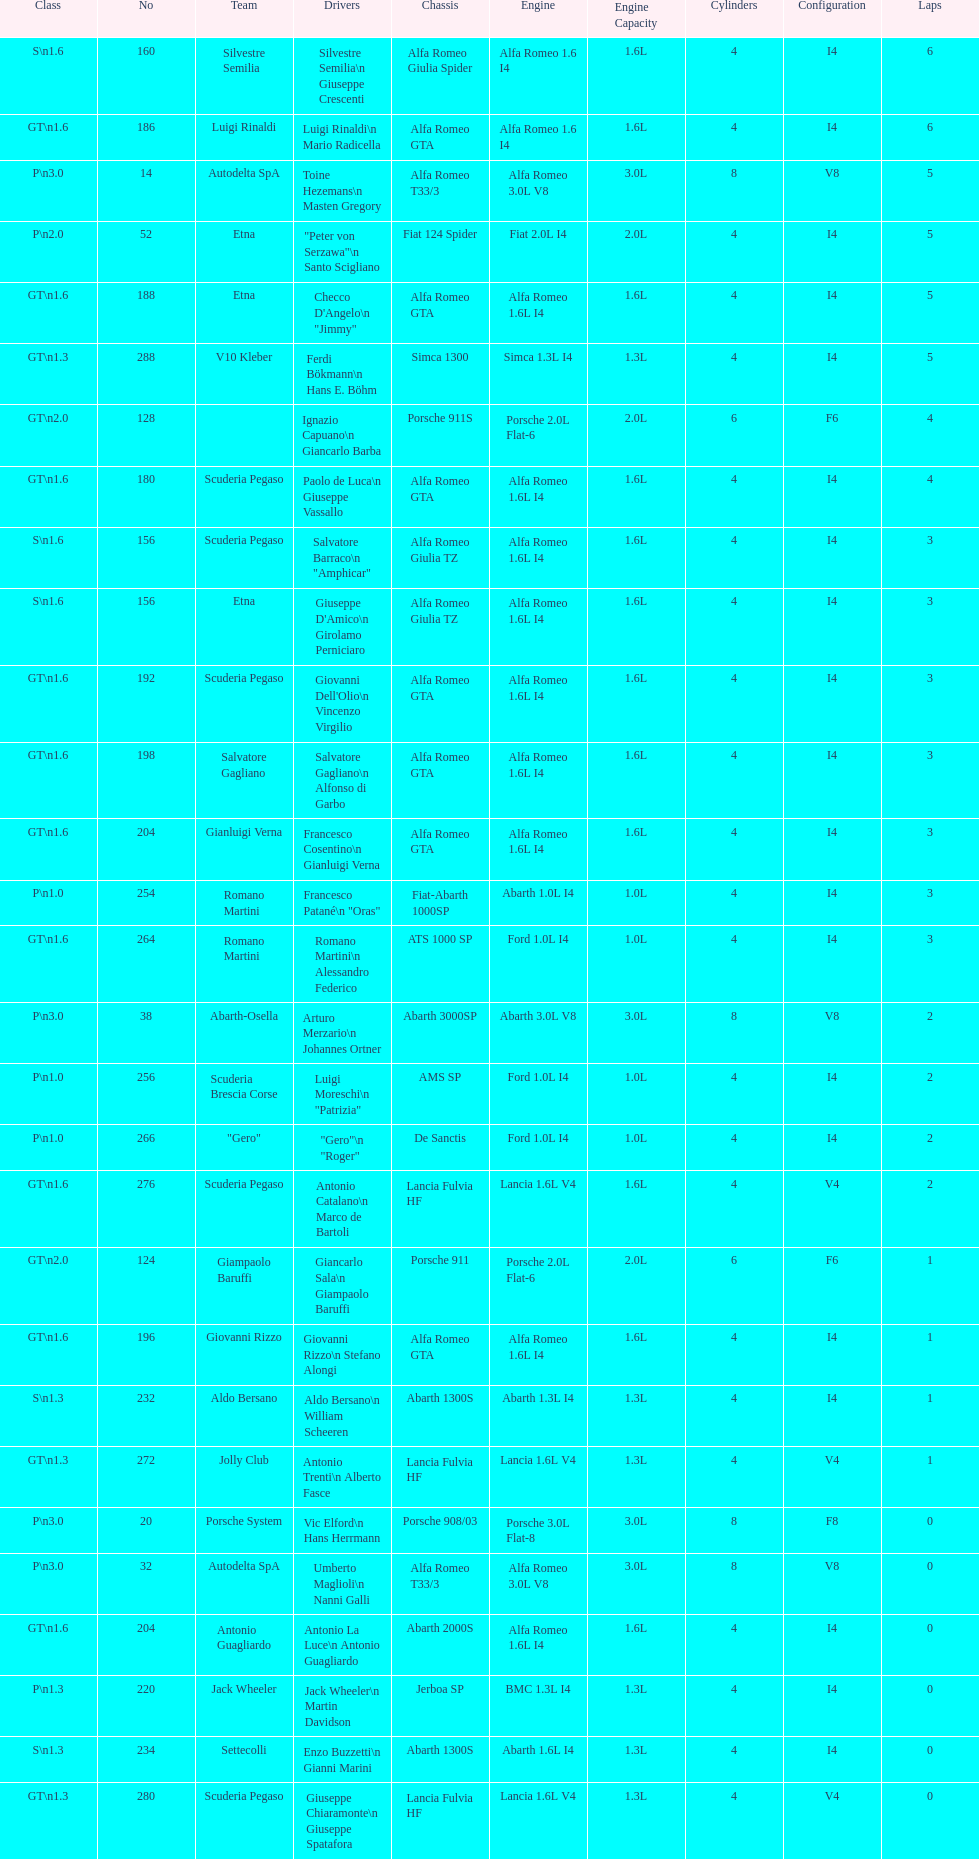Name the only american who did not finish the race. Masten Gregory. 